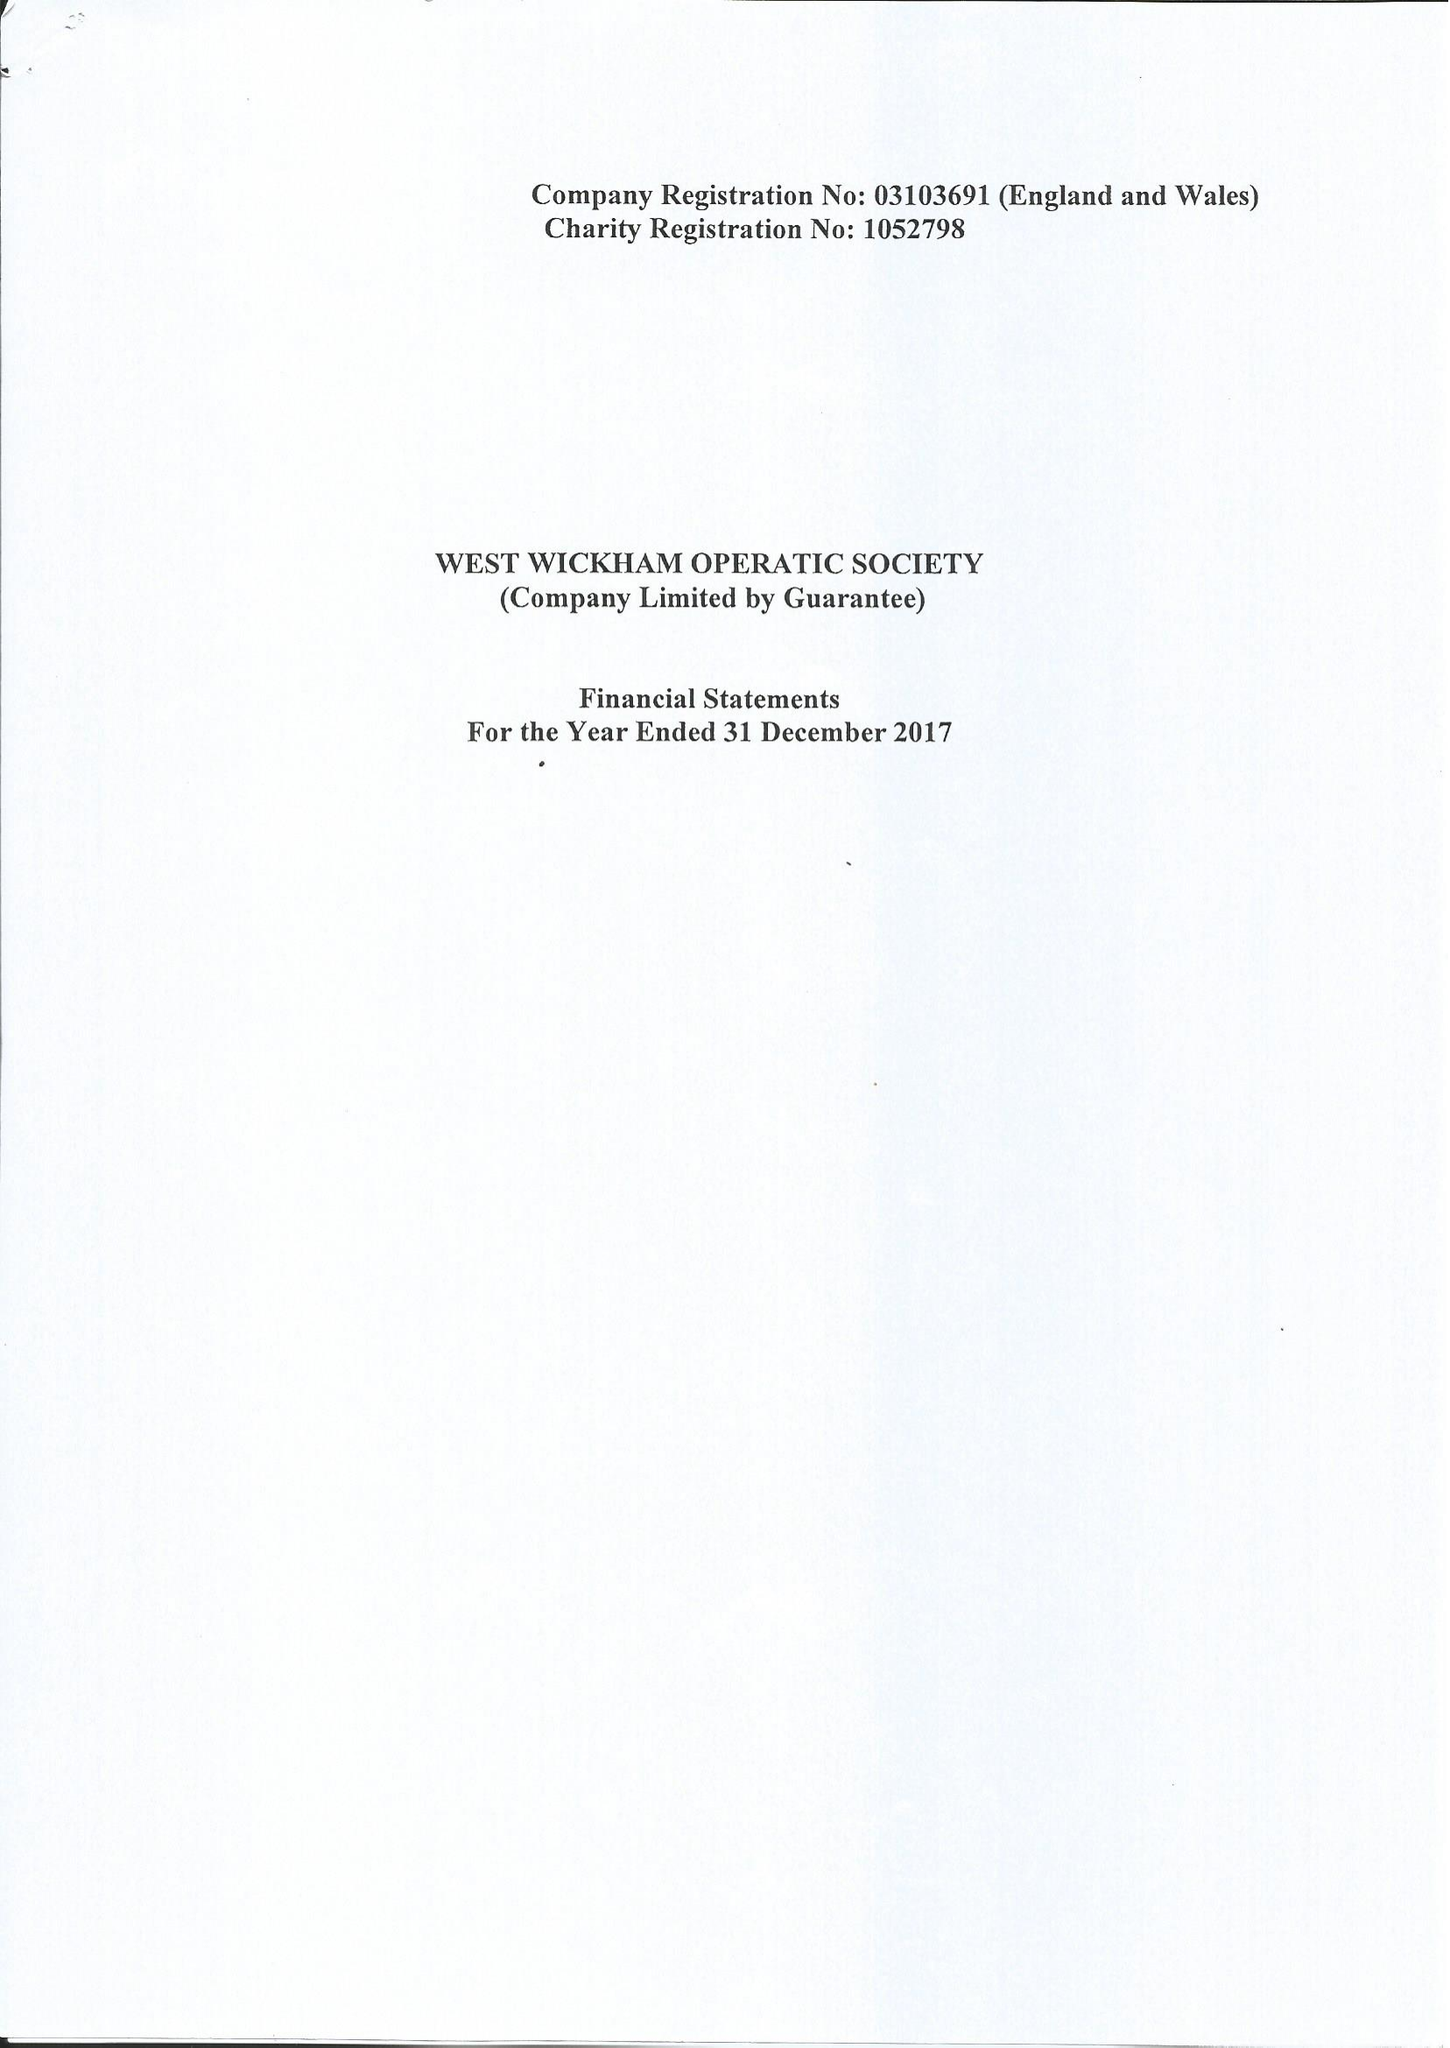What is the value for the charity_name?
Answer the question using a single word or phrase. West Wickham Operatic Society 